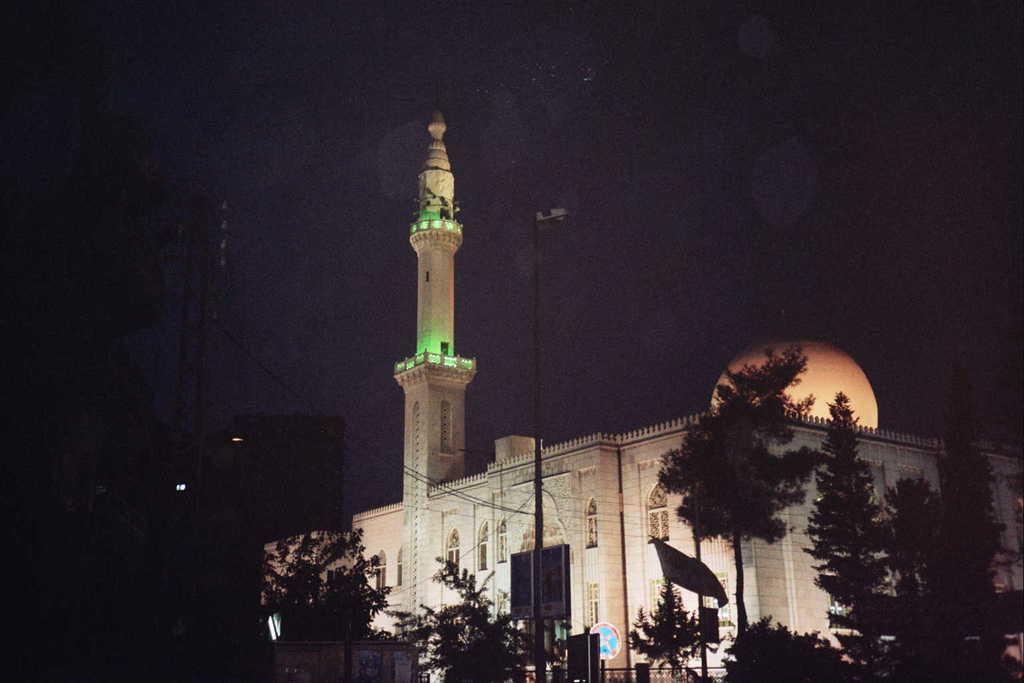Please provide a concise description of this image. In the foreground of this image, there are trees and poles. We can also see a building, moon and the dark sky. 